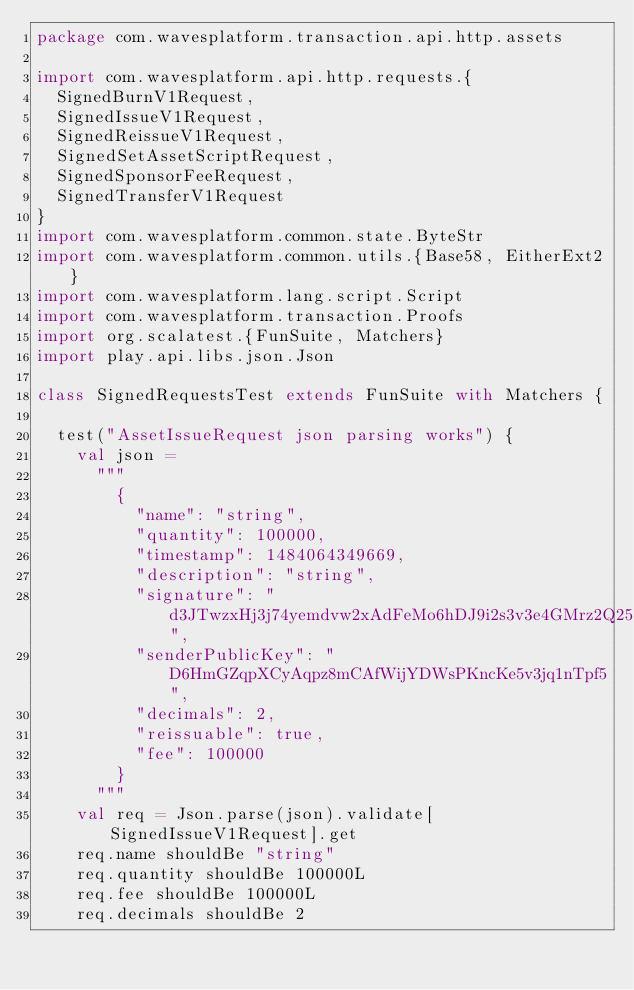<code> <loc_0><loc_0><loc_500><loc_500><_Scala_>package com.wavesplatform.transaction.api.http.assets

import com.wavesplatform.api.http.requests.{
  SignedBurnV1Request,
  SignedIssueV1Request,
  SignedReissueV1Request,
  SignedSetAssetScriptRequest,
  SignedSponsorFeeRequest,
  SignedTransferV1Request
}
import com.wavesplatform.common.state.ByteStr
import com.wavesplatform.common.utils.{Base58, EitherExt2}
import com.wavesplatform.lang.script.Script
import com.wavesplatform.transaction.Proofs
import org.scalatest.{FunSuite, Matchers}
import play.api.libs.json.Json

class SignedRequestsTest extends FunSuite with Matchers {

  test("AssetIssueRequest json parsing works") {
    val json =
      """
        {
          "name": "string",
          "quantity": 100000,
          "timestamp": 1484064349669,
          "description": "string",
          "signature": "d3JTwzxHj3j74yemdvw2xAdFeMo6hDJ9i2s3v3e4GMrz2Q25G89Pp3HyXfKk3mwNcKWjtyoTWvTt1eLk2KzetoL",
          "senderPublicKey": "D6HmGZqpXCyAqpz8mCAfWijYDWsPKncKe5v3jq1nTpf5",
          "decimals": 2,
          "reissuable": true,
          "fee": 100000
        }
      """
    val req = Json.parse(json).validate[SignedIssueV1Request].get
    req.name shouldBe "string"
    req.quantity shouldBe 100000L
    req.fee shouldBe 100000L
    req.decimals shouldBe 2</code> 